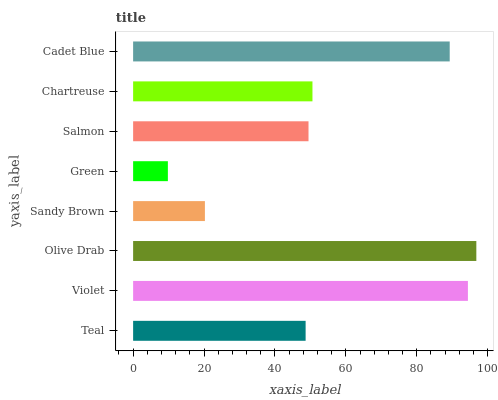Is Green the minimum?
Answer yes or no. Yes. Is Olive Drab the maximum?
Answer yes or no. Yes. Is Violet the minimum?
Answer yes or no. No. Is Violet the maximum?
Answer yes or no. No. Is Violet greater than Teal?
Answer yes or no. Yes. Is Teal less than Violet?
Answer yes or no. Yes. Is Teal greater than Violet?
Answer yes or no. No. Is Violet less than Teal?
Answer yes or no. No. Is Chartreuse the high median?
Answer yes or no. Yes. Is Salmon the low median?
Answer yes or no. Yes. Is Cadet Blue the high median?
Answer yes or no. No. Is Green the low median?
Answer yes or no. No. 